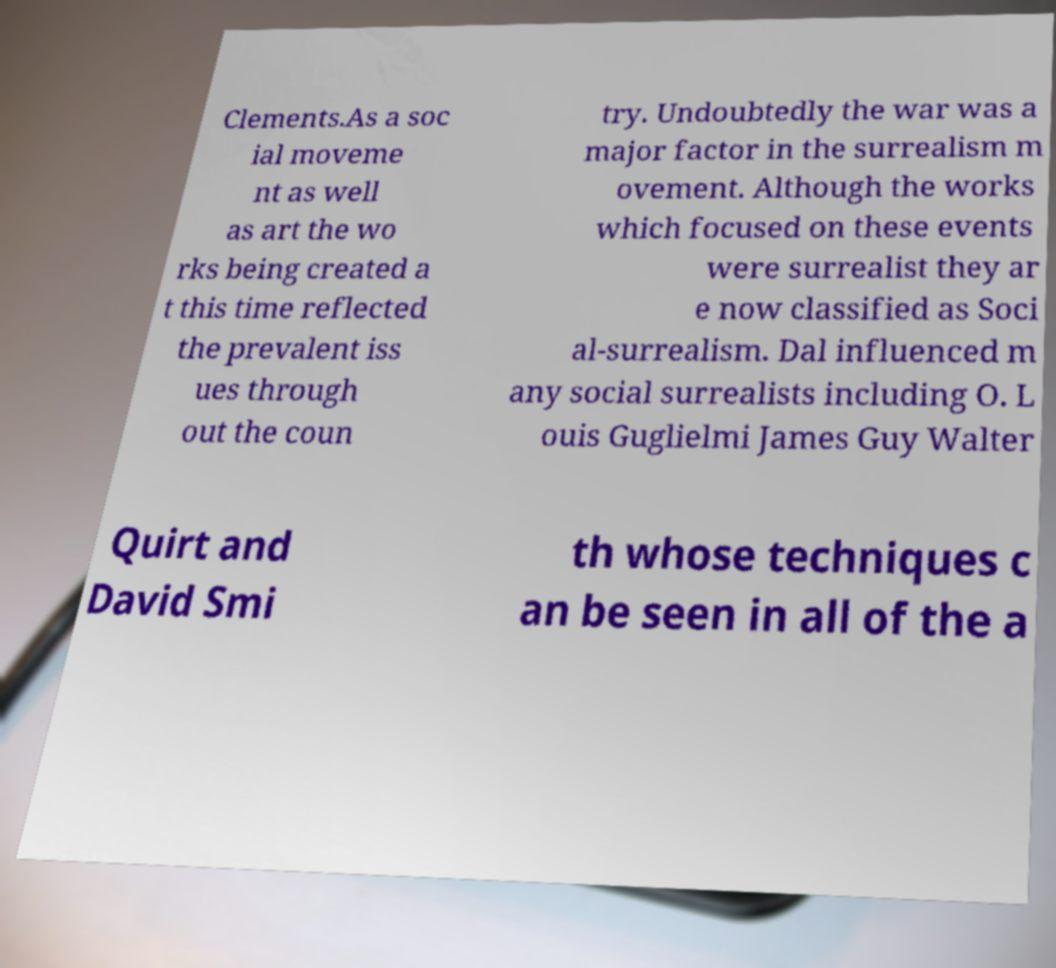There's text embedded in this image that I need extracted. Can you transcribe it verbatim? Clements.As a soc ial moveme nt as well as art the wo rks being created a t this time reflected the prevalent iss ues through out the coun try. Undoubtedly the war was a major factor in the surrealism m ovement. Although the works which focused on these events were surrealist they ar e now classified as Soci al-surrealism. Dal influenced m any social surrealists including O. L ouis Guglielmi James Guy Walter Quirt and David Smi th whose techniques c an be seen in all of the a 